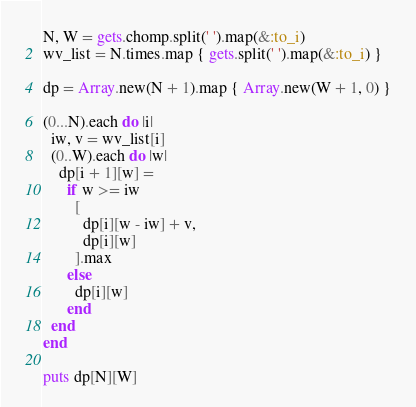Convert code to text. <code><loc_0><loc_0><loc_500><loc_500><_Ruby_>N, W = gets.chomp.split(' ').map(&:to_i)
wv_list = N.times.map { gets.split(' ').map(&:to_i) }

dp = Array.new(N + 1).map { Array.new(W + 1, 0) }

(0...N).each do |i|
  iw, v = wv_list[i]
  (0..W).each do |w|
    dp[i + 1][w] =
      if w >= iw
        [
          dp[i][w - iw] + v,
          dp[i][w]
        ].max
      else
        dp[i][w]
      end
  end
end

puts dp[N][W]
</code> 